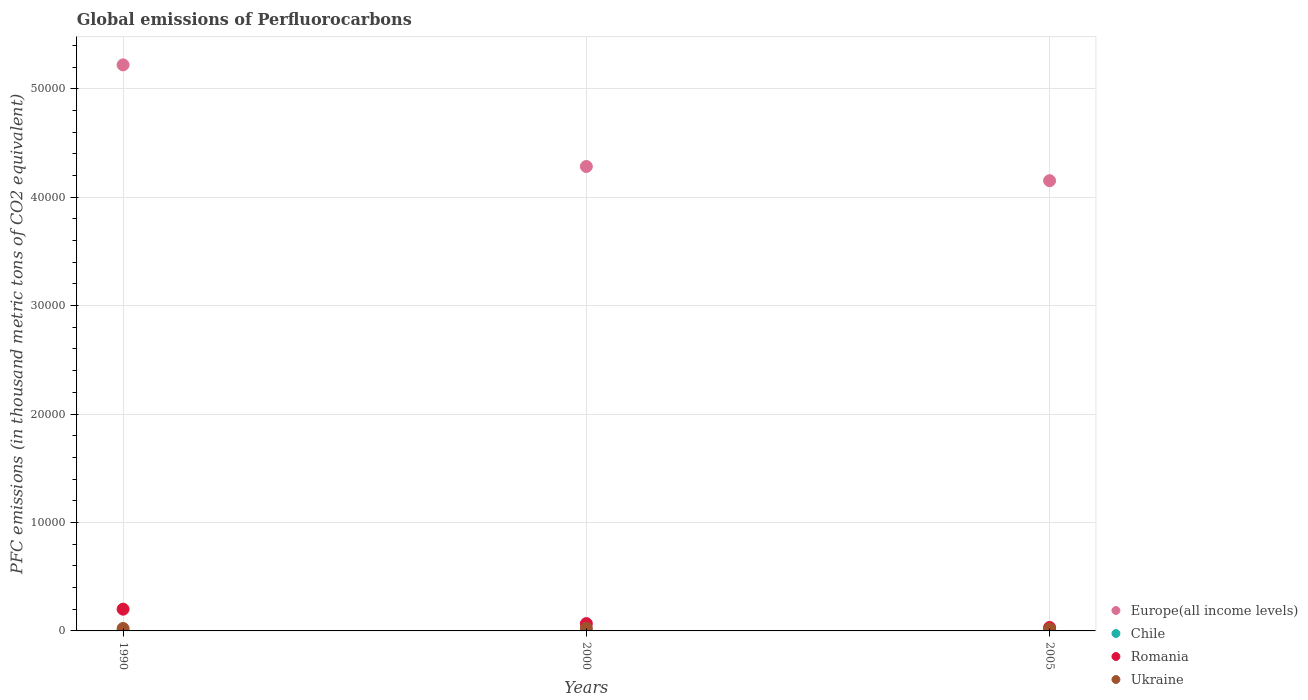How many different coloured dotlines are there?
Your answer should be compact. 4. Is the number of dotlines equal to the number of legend labels?
Make the answer very short. Yes. What is the global emissions of Perfluorocarbons in Romania in 1990?
Provide a succinct answer. 2006.1. Across all years, what is the maximum global emissions of Perfluorocarbons in Romania?
Provide a succinct answer. 2006.1. Across all years, what is the minimum global emissions of Perfluorocarbons in Romania?
Provide a short and direct response. 321.3. In which year was the global emissions of Perfluorocarbons in Ukraine minimum?
Ensure brevity in your answer.  2005. What is the total global emissions of Perfluorocarbons in Romania in the graph?
Your answer should be compact. 3002.3. What is the difference between the global emissions of Perfluorocarbons in Ukraine in 2000 and that in 2005?
Provide a succinct answer. 63.6. What is the difference between the global emissions of Perfluorocarbons in Chile in 1990 and the global emissions of Perfluorocarbons in Europe(all income levels) in 2000?
Your response must be concise. -4.28e+04. What is the average global emissions of Perfluorocarbons in Ukraine per year?
Your answer should be very brief. 216.2. In the year 2005, what is the difference between the global emissions of Perfluorocarbons in Chile and global emissions of Perfluorocarbons in Europe(all income levels)?
Ensure brevity in your answer.  -4.15e+04. What is the ratio of the global emissions of Perfluorocarbons in Romania in 1990 to that in 2005?
Your response must be concise. 6.24. Is the global emissions of Perfluorocarbons in Romania in 1990 less than that in 2005?
Keep it short and to the point. No. What is the difference between the highest and the lowest global emissions of Perfluorocarbons in Chile?
Ensure brevity in your answer.  0. In how many years, is the global emissions of Perfluorocarbons in Ukraine greater than the average global emissions of Perfluorocarbons in Ukraine taken over all years?
Your response must be concise. 2. How many years are there in the graph?
Keep it short and to the point. 3. Does the graph contain any zero values?
Give a very brief answer. No. Does the graph contain grids?
Provide a succinct answer. Yes. How are the legend labels stacked?
Your response must be concise. Vertical. What is the title of the graph?
Your response must be concise. Global emissions of Perfluorocarbons. What is the label or title of the Y-axis?
Your response must be concise. PFC emissions (in thousand metric tons of CO2 equivalent). What is the PFC emissions (in thousand metric tons of CO2 equivalent) of Europe(all income levels) in 1990?
Offer a very short reply. 5.22e+04. What is the PFC emissions (in thousand metric tons of CO2 equivalent) of Chile in 1990?
Provide a short and direct response. 0.2. What is the PFC emissions (in thousand metric tons of CO2 equivalent) in Romania in 1990?
Your response must be concise. 2006.1. What is the PFC emissions (in thousand metric tons of CO2 equivalent) of Ukraine in 1990?
Make the answer very short. 224. What is the PFC emissions (in thousand metric tons of CO2 equivalent) in Europe(all income levels) in 2000?
Your response must be concise. 4.28e+04. What is the PFC emissions (in thousand metric tons of CO2 equivalent) in Romania in 2000?
Your answer should be compact. 674.9. What is the PFC emissions (in thousand metric tons of CO2 equivalent) in Ukraine in 2000?
Give a very brief answer. 244.1. What is the PFC emissions (in thousand metric tons of CO2 equivalent) of Europe(all income levels) in 2005?
Ensure brevity in your answer.  4.15e+04. What is the PFC emissions (in thousand metric tons of CO2 equivalent) in Chile in 2005?
Ensure brevity in your answer.  0.2. What is the PFC emissions (in thousand metric tons of CO2 equivalent) of Romania in 2005?
Your response must be concise. 321.3. What is the PFC emissions (in thousand metric tons of CO2 equivalent) in Ukraine in 2005?
Your answer should be very brief. 180.5. Across all years, what is the maximum PFC emissions (in thousand metric tons of CO2 equivalent) in Europe(all income levels)?
Offer a very short reply. 5.22e+04. Across all years, what is the maximum PFC emissions (in thousand metric tons of CO2 equivalent) of Romania?
Keep it short and to the point. 2006.1. Across all years, what is the maximum PFC emissions (in thousand metric tons of CO2 equivalent) in Ukraine?
Provide a short and direct response. 244.1. Across all years, what is the minimum PFC emissions (in thousand metric tons of CO2 equivalent) of Europe(all income levels)?
Your answer should be very brief. 4.15e+04. Across all years, what is the minimum PFC emissions (in thousand metric tons of CO2 equivalent) in Chile?
Offer a very short reply. 0.2. Across all years, what is the minimum PFC emissions (in thousand metric tons of CO2 equivalent) of Romania?
Give a very brief answer. 321.3. Across all years, what is the minimum PFC emissions (in thousand metric tons of CO2 equivalent) in Ukraine?
Offer a terse response. 180.5. What is the total PFC emissions (in thousand metric tons of CO2 equivalent) in Europe(all income levels) in the graph?
Your response must be concise. 1.37e+05. What is the total PFC emissions (in thousand metric tons of CO2 equivalent) of Romania in the graph?
Provide a short and direct response. 3002.3. What is the total PFC emissions (in thousand metric tons of CO2 equivalent) in Ukraine in the graph?
Your answer should be compact. 648.6. What is the difference between the PFC emissions (in thousand metric tons of CO2 equivalent) of Europe(all income levels) in 1990 and that in 2000?
Make the answer very short. 9372.1. What is the difference between the PFC emissions (in thousand metric tons of CO2 equivalent) in Chile in 1990 and that in 2000?
Give a very brief answer. 0. What is the difference between the PFC emissions (in thousand metric tons of CO2 equivalent) of Romania in 1990 and that in 2000?
Provide a succinct answer. 1331.2. What is the difference between the PFC emissions (in thousand metric tons of CO2 equivalent) of Ukraine in 1990 and that in 2000?
Your answer should be very brief. -20.1. What is the difference between the PFC emissions (in thousand metric tons of CO2 equivalent) in Europe(all income levels) in 1990 and that in 2005?
Offer a very short reply. 1.07e+04. What is the difference between the PFC emissions (in thousand metric tons of CO2 equivalent) in Romania in 1990 and that in 2005?
Provide a short and direct response. 1684.8. What is the difference between the PFC emissions (in thousand metric tons of CO2 equivalent) of Ukraine in 1990 and that in 2005?
Provide a short and direct response. 43.5. What is the difference between the PFC emissions (in thousand metric tons of CO2 equivalent) of Europe(all income levels) in 2000 and that in 2005?
Make the answer very short. 1308.31. What is the difference between the PFC emissions (in thousand metric tons of CO2 equivalent) of Chile in 2000 and that in 2005?
Keep it short and to the point. 0. What is the difference between the PFC emissions (in thousand metric tons of CO2 equivalent) of Romania in 2000 and that in 2005?
Your response must be concise. 353.6. What is the difference between the PFC emissions (in thousand metric tons of CO2 equivalent) of Ukraine in 2000 and that in 2005?
Make the answer very short. 63.6. What is the difference between the PFC emissions (in thousand metric tons of CO2 equivalent) in Europe(all income levels) in 1990 and the PFC emissions (in thousand metric tons of CO2 equivalent) in Chile in 2000?
Keep it short and to the point. 5.22e+04. What is the difference between the PFC emissions (in thousand metric tons of CO2 equivalent) in Europe(all income levels) in 1990 and the PFC emissions (in thousand metric tons of CO2 equivalent) in Romania in 2000?
Provide a short and direct response. 5.15e+04. What is the difference between the PFC emissions (in thousand metric tons of CO2 equivalent) of Europe(all income levels) in 1990 and the PFC emissions (in thousand metric tons of CO2 equivalent) of Ukraine in 2000?
Give a very brief answer. 5.20e+04. What is the difference between the PFC emissions (in thousand metric tons of CO2 equivalent) of Chile in 1990 and the PFC emissions (in thousand metric tons of CO2 equivalent) of Romania in 2000?
Make the answer very short. -674.7. What is the difference between the PFC emissions (in thousand metric tons of CO2 equivalent) of Chile in 1990 and the PFC emissions (in thousand metric tons of CO2 equivalent) of Ukraine in 2000?
Your response must be concise. -243.9. What is the difference between the PFC emissions (in thousand metric tons of CO2 equivalent) in Romania in 1990 and the PFC emissions (in thousand metric tons of CO2 equivalent) in Ukraine in 2000?
Ensure brevity in your answer.  1762. What is the difference between the PFC emissions (in thousand metric tons of CO2 equivalent) of Europe(all income levels) in 1990 and the PFC emissions (in thousand metric tons of CO2 equivalent) of Chile in 2005?
Keep it short and to the point. 5.22e+04. What is the difference between the PFC emissions (in thousand metric tons of CO2 equivalent) in Europe(all income levels) in 1990 and the PFC emissions (in thousand metric tons of CO2 equivalent) in Romania in 2005?
Provide a short and direct response. 5.19e+04. What is the difference between the PFC emissions (in thousand metric tons of CO2 equivalent) of Europe(all income levels) in 1990 and the PFC emissions (in thousand metric tons of CO2 equivalent) of Ukraine in 2005?
Make the answer very short. 5.20e+04. What is the difference between the PFC emissions (in thousand metric tons of CO2 equivalent) of Chile in 1990 and the PFC emissions (in thousand metric tons of CO2 equivalent) of Romania in 2005?
Ensure brevity in your answer.  -321.1. What is the difference between the PFC emissions (in thousand metric tons of CO2 equivalent) in Chile in 1990 and the PFC emissions (in thousand metric tons of CO2 equivalent) in Ukraine in 2005?
Provide a short and direct response. -180.3. What is the difference between the PFC emissions (in thousand metric tons of CO2 equivalent) of Romania in 1990 and the PFC emissions (in thousand metric tons of CO2 equivalent) of Ukraine in 2005?
Keep it short and to the point. 1825.6. What is the difference between the PFC emissions (in thousand metric tons of CO2 equivalent) of Europe(all income levels) in 2000 and the PFC emissions (in thousand metric tons of CO2 equivalent) of Chile in 2005?
Make the answer very short. 4.28e+04. What is the difference between the PFC emissions (in thousand metric tons of CO2 equivalent) of Europe(all income levels) in 2000 and the PFC emissions (in thousand metric tons of CO2 equivalent) of Romania in 2005?
Provide a short and direct response. 4.25e+04. What is the difference between the PFC emissions (in thousand metric tons of CO2 equivalent) in Europe(all income levels) in 2000 and the PFC emissions (in thousand metric tons of CO2 equivalent) in Ukraine in 2005?
Provide a succinct answer. 4.26e+04. What is the difference between the PFC emissions (in thousand metric tons of CO2 equivalent) of Chile in 2000 and the PFC emissions (in thousand metric tons of CO2 equivalent) of Romania in 2005?
Provide a succinct answer. -321.1. What is the difference between the PFC emissions (in thousand metric tons of CO2 equivalent) of Chile in 2000 and the PFC emissions (in thousand metric tons of CO2 equivalent) of Ukraine in 2005?
Make the answer very short. -180.3. What is the difference between the PFC emissions (in thousand metric tons of CO2 equivalent) of Romania in 2000 and the PFC emissions (in thousand metric tons of CO2 equivalent) of Ukraine in 2005?
Make the answer very short. 494.4. What is the average PFC emissions (in thousand metric tons of CO2 equivalent) in Europe(all income levels) per year?
Make the answer very short. 4.55e+04. What is the average PFC emissions (in thousand metric tons of CO2 equivalent) in Chile per year?
Provide a short and direct response. 0.2. What is the average PFC emissions (in thousand metric tons of CO2 equivalent) of Romania per year?
Your answer should be compact. 1000.77. What is the average PFC emissions (in thousand metric tons of CO2 equivalent) of Ukraine per year?
Offer a terse response. 216.2. In the year 1990, what is the difference between the PFC emissions (in thousand metric tons of CO2 equivalent) of Europe(all income levels) and PFC emissions (in thousand metric tons of CO2 equivalent) of Chile?
Offer a terse response. 5.22e+04. In the year 1990, what is the difference between the PFC emissions (in thousand metric tons of CO2 equivalent) in Europe(all income levels) and PFC emissions (in thousand metric tons of CO2 equivalent) in Romania?
Your answer should be very brief. 5.02e+04. In the year 1990, what is the difference between the PFC emissions (in thousand metric tons of CO2 equivalent) in Europe(all income levels) and PFC emissions (in thousand metric tons of CO2 equivalent) in Ukraine?
Make the answer very short. 5.20e+04. In the year 1990, what is the difference between the PFC emissions (in thousand metric tons of CO2 equivalent) of Chile and PFC emissions (in thousand metric tons of CO2 equivalent) of Romania?
Offer a very short reply. -2005.9. In the year 1990, what is the difference between the PFC emissions (in thousand metric tons of CO2 equivalent) of Chile and PFC emissions (in thousand metric tons of CO2 equivalent) of Ukraine?
Offer a very short reply. -223.8. In the year 1990, what is the difference between the PFC emissions (in thousand metric tons of CO2 equivalent) of Romania and PFC emissions (in thousand metric tons of CO2 equivalent) of Ukraine?
Keep it short and to the point. 1782.1. In the year 2000, what is the difference between the PFC emissions (in thousand metric tons of CO2 equivalent) of Europe(all income levels) and PFC emissions (in thousand metric tons of CO2 equivalent) of Chile?
Offer a very short reply. 4.28e+04. In the year 2000, what is the difference between the PFC emissions (in thousand metric tons of CO2 equivalent) in Europe(all income levels) and PFC emissions (in thousand metric tons of CO2 equivalent) in Romania?
Provide a succinct answer. 4.22e+04. In the year 2000, what is the difference between the PFC emissions (in thousand metric tons of CO2 equivalent) in Europe(all income levels) and PFC emissions (in thousand metric tons of CO2 equivalent) in Ukraine?
Provide a succinct answer. 4.26e+04. In the year 2000, what is the difference between the PFC emissions (in thousand metric tons of CO2 equivalent) in Chile and PFC emissions (in thousand metric tons of CO2 equivalent) in Romania?
Make the answer very short. -674.7. In the year 2000, what is the difference between the PFC emissions (in thousand metric tons of CO2 equivalent) in Chile and PFC emissions (in thousand metric tons of CO2 equivalent) in Ukraine?
Your answer should be compact. -243.9. In the year 2000, what is the difference between the PFC emissions (in thousand metric tons of CO2 equivalent) in Romania and PFC emissions (in thousand metric tons of CO2 equivalent) in Ukraine?
Your answer should be very brief. 430.8. In the year 2005, what is the difference between the PFC emissions (in thousand metric tons of CO2 equivalent) of Europe(all income levels) and PFC emissions (in thousand metric tons of CO2 equivalent) of Chile?
Your answer should be compact. 4.15e+04. In the year 2005, what is the difference between the PFC emissions (in thousand metric tons of CO2 equivalent) in Europe(all income levels) and PFC emissions (in thousand metric tons of CO2 equivalent) in Romania?
Offer a very short reply. 4.12e+04. In the year 2005, what is the difference between the PFC emissions (in thousand metric tons of CO2 equivalent) in Europe(all income levels) and PFC emissions (in thousand metric tons of CO2 equivalent) in Ukraine?
Give a very brief answer. 4.13e+04. In the year 2005, what is the difference between the PFC emissions (in thousand metric tons of CO2 equivalent) in Chile and PFC emissions (in thousand metric tons of CO2 equivalent) in Romania?
Your response must be concise. -321.1. In the year 2005, what is the difference between the PFC emissions (in thousand metric tons of CO2 equivalent) of Chile and PFC emissions (in thousand metric tons of CO2 equivalent) of Ukraine?
Your answer should be compact. -180.3. In the year 2005, what is the difference between the PFC emissions (in thousand metric tons of CO2 equivalent) in Romania and PFC emissions (in thousand metric tons of CO2 equivalent) in Ukraine?
Your answer should be compact. 140.8. What is the ratio of the PFC emissions (in thousand metric tons of CO2 equivalent) in Europe(all income levels) in 1990 to that in 2000?
Give a very brief answer. 1.22. What is the ratio of the PFC emissions (in thousand metric tons of CO2 equivalent) of Chile in 1990 to that in 2000?
Ensure brevity in your answer.  1. What is the ratio of the PFC emissions (in thousand metric tons of CO2 equivalent) in Romania in 1990 to that in 2000?
Keep it short and to the point. 2.97. What is the ratio of the PFC emissions (in thousand metric tons of CO2 equivalent) in Ukraine in 1990 to that in 2000?
Ensure brevity in your answer.  0.92. What is the ratio of the PFC emissions (in thousand metric tons of CO2 equivalent) of Europe(all income levels) in 1990 to that in 2005?
Your answer should be compact. 1.26. What is the ratio of the PFC emissions (in thousand metric tons of CO2 equivalent) of Romania in 1990 to that in 2005?
Your answer should be very brief. 6.24. What is the ratio of the PFC emissions (in thousand metric tons of CO2 equivalent) of Ukraine in 1990 to that in 2005?
Your response must be concise. 1.24. What is the ratio of the PFC emissions (in thousand metric tons of CO2 equivalent) in Europe(all income levels) in 2000 to that in 2005?
Offer a terse response. 1.03. What is the ratio of the PFC emissions (in thousand metric tons of CO2 equivalent) in Chile in 2000 to that in 2005?
Ensure brevity in your answer.  1. What is the ratio of the PFC emissions (in thousand metric tons of CO2 equivalent) in Romania in 2000 to that in 2005?
Your answer should be very brief. 2.1. What is the ratio of the PFC emissions (in thousand metric tons of CO2 equivalent) of Ukraine in 2000 to that in 2005?
Keep it short and to the point. 1.35. What is the difference between the highest and the second highest PFC emissions (in thousand metric tons of CO2 equivalent) of Europe(all income levels)?
Ensure brevity in your answer.  9372.1. What is the difference between the highest and the second highest PFC emissions (in thousand metric tons of CO2 equivalent) of Romania?
Ensure brevity in your answer.  1331.2. What is the difference between the highest and the second highest PFC emissions (in thousand metric tons of CO2 equivalent) in Ukraine?
Your answer should be very brief. 20.1. What is the difference between the highest and the lowest PFC emissions (in thousand metric tons of CO2 equivalent) in Europe(all income levels)?
Offer a very short reply. 1.07e+04. What is the difference between the highest and the lowest PFC emissions (in thousand metric tons of CO2 equivalent) of Chile?
Keep it short and to the point. 0. What is the difference between the highest and the lowest PFC emissions (in thousand metric tons of CO2 equivalent) in Romania?
Keep it short and to the point. 1684.8. What is the difference between the highest and the lowest PFC emissions (in thousand metric tons of CO2 equivalent) in Ukraine?
Provide a short and direct response. 63.6. 